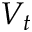<formula> <loc_0><loc_0><loc_500><loc_500>V _ { t }</formula> 